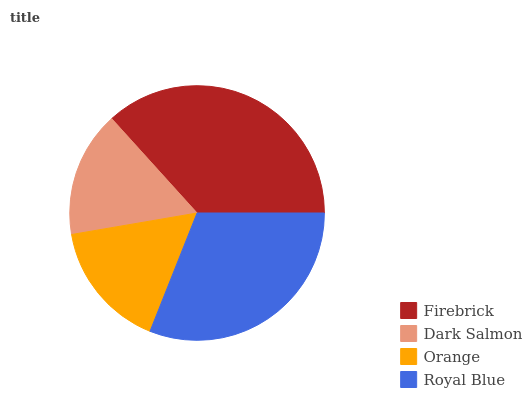Is Dark Salmon the minimum?
Answer yes or no. Yes. Is Firebrick the maximum?
Answer yes or no. Yes. Is Orange the minimum?
Answer yes or no. No. Is Orange the maximum?
Answer yes or no. No. Is Orange greater than Dark Salmon?
Answer yes or no. Yes. Is Dark Salmon less than Orange?
Answer yes or no. Yes. Is Dark Salmon greater than Orange?
Answer yes or no. No. Is Orange less than Dark Salmon?
Answer yes or no. No. Is Royal Blue the high median?
Answer yes or no. Yes. Is Orange the low median?
Answer yes or no. Yes. Is Orange the high median?
Answer yes or no. No. Is Royal Blue the low median?
Answer yes or no. No. 